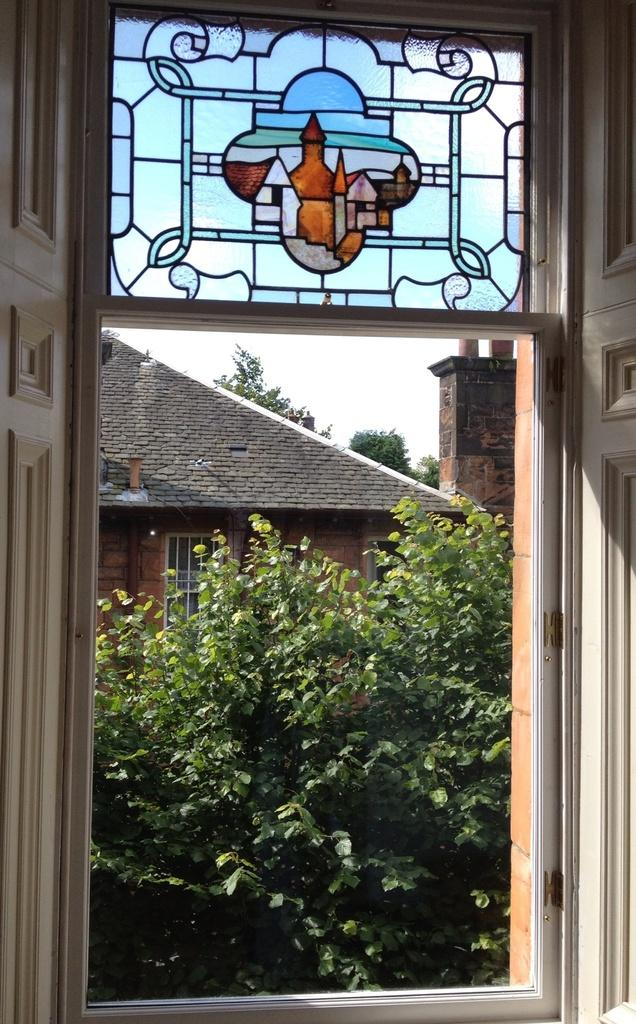What type of window is depicted in the image? There is a window with doors in the image. What can be seen inside the window? There is a stained glass with an art in the window. What type of vegetation is visible in the image? There are trees visible in the image. What type of structure is shown in the image? There is a house in the image. What is visible in the background of the image? The sky is visible in the image. What color is the ink used to draw the art on the stained glass? There is no mention of ink being used to create the art on the stained glass. The art is likely created using colored glass pieces. What type of fruit can be seen on the marble countertop in the image? There is no mention of a marble countertop or fruit in the image. 